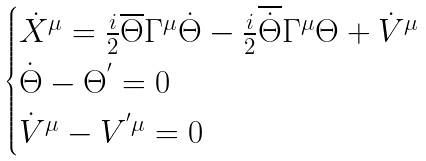Convert formula to latex. <formula><loc_0><loc_0><loc_500><loc_500>\begin{cases} { \dot { X } } ^ { \mu } = \frac { i } { 2 } \overline { \Theta } { \Gamma } ^ { \mu } \dot { \Theta } - \frac { i } { 2 } \overline { \dot { \Theta } } { \Gamma } ^ { \mu } \Theta + { \dot { V } } ^ { \mu } \\ \dot { \Theta } - { \Theta } ^ { ^ { \prime } } = 0 \\ { \dot { V } } ^ { \mu } - V ^ { ^ { \prime } \mu } = 0 \end{cases}</formula> 